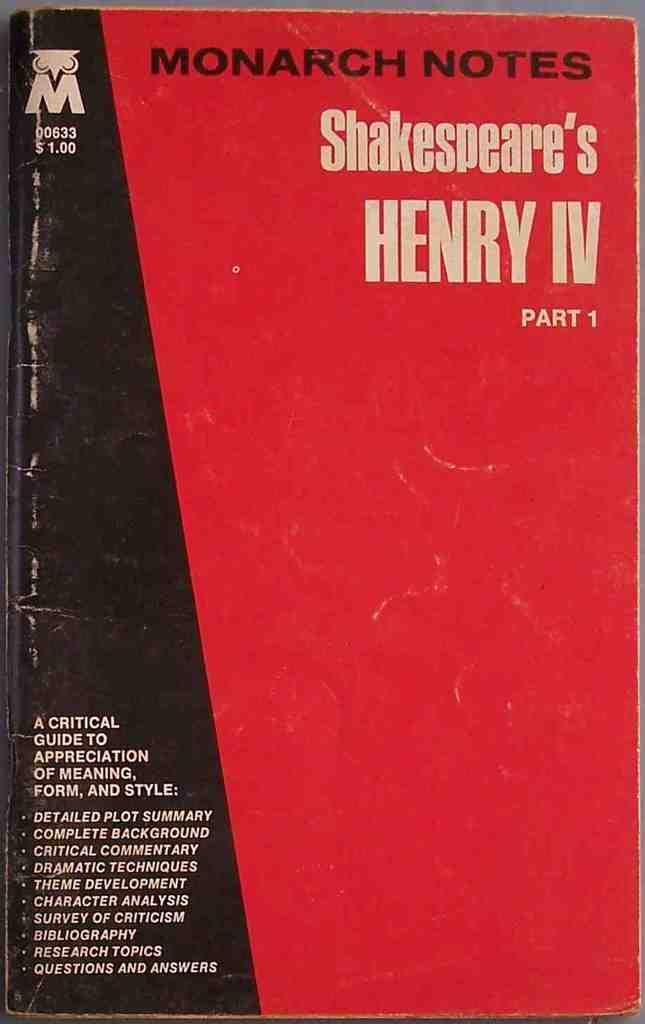What educational benefits could one gain from this Monarch Notes book? This Monarch Notes book provides comprehensive study materials such as detailed plot summaries, character analysis, and thematic exploration that can help deepen understanding of Shakespeare's nuanced storytelling and complex characters in 'Henry IV Part 1.' How might this book cater to different audiences interested in Shakespeare? Experts will appreciate the critical commentary and bibliographic references, while students may find the plot summaries and study questions particularly beneficial, making it a versatile resource for a variety of audiences. 